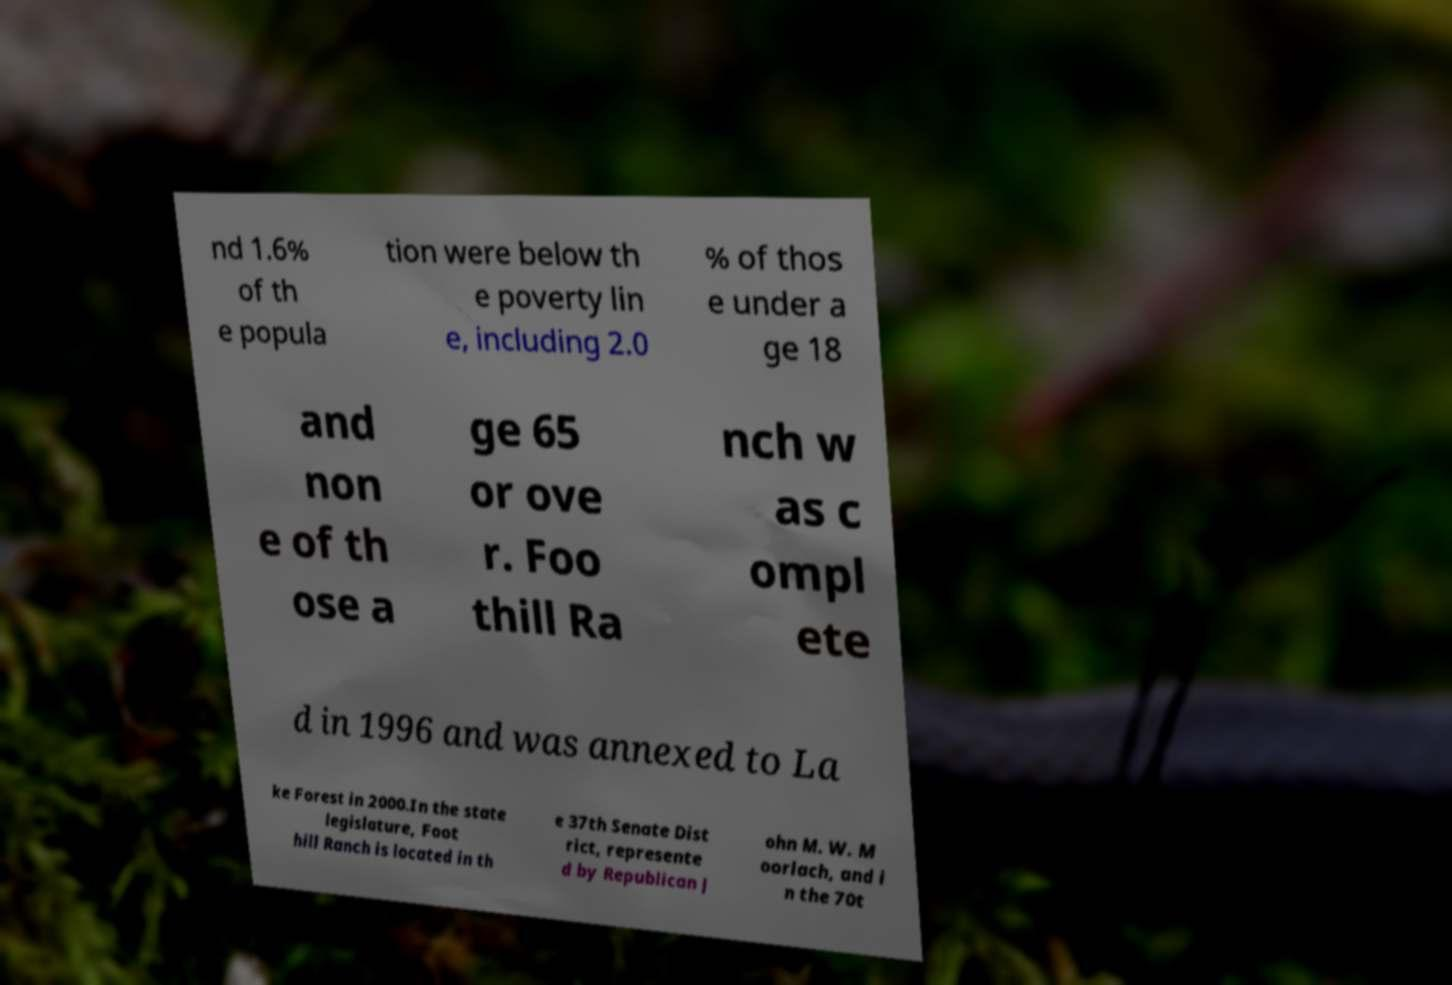For documentation purposes, I need the text within this image transcribed. Could you provide that? nd 1.6% of th e popula tion were below th e poverty lin e, including 2.0 % of thos e under a ge 18 and non e of th ose a ge 65 or ove r. Foo thill Ra nch w as c ompl ete d in 1996 and was annexed to La ke Forest in 2000.In the state legislature, Foot hill Ranch is located in th e 37th Senate Dist rict, represente d by Republican J ohn M. W. M oorlach, and i n the 70t 